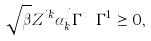<formula> <loc_0><loc_0><loc_500><loc_500>\sqrt { \beta } Z ^ { i k } \alpha _ { k } ^ { j } \Gamma ^ { t } \cdots \Gamma ^ { 1 } \geq 0 ,</formula> 